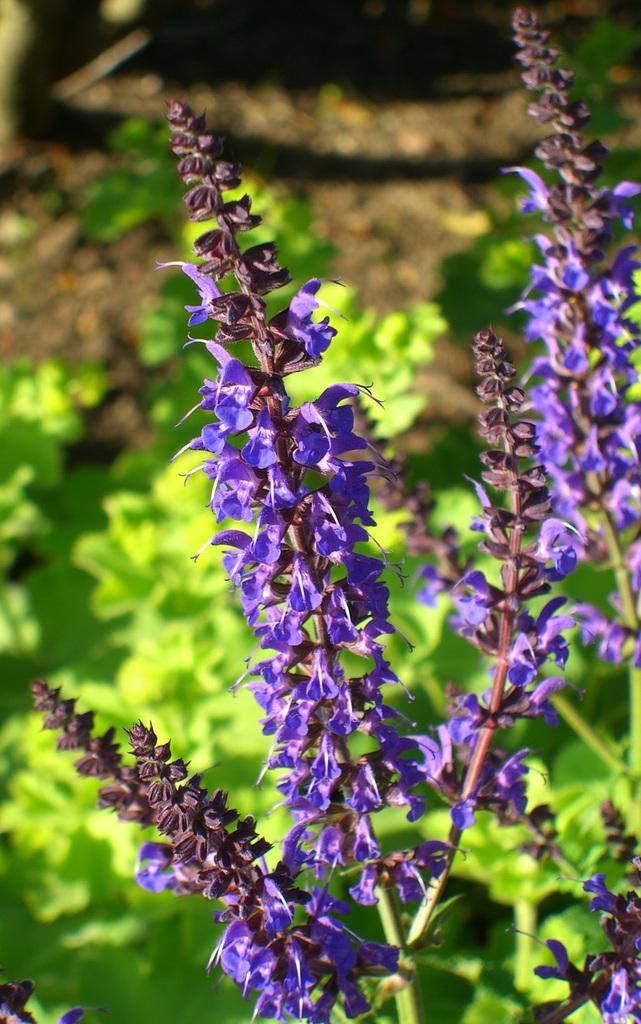What is located in the foreground of the image? There are flowers in the foreground of the image. What can be seen at the bottom of the image? There are plants at the bottom of the image. What type of terrain is visible in the image? There is sand visible in the image. How many spots can be seen on the insect in the image? There is no insect present in the image, so it is not possible to determine the number of spots on an insect. 